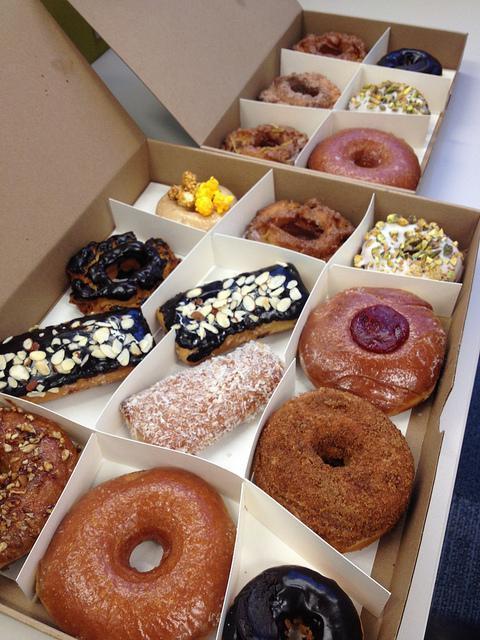How many donuts are in the picture?
Give a very brief answer. 13. How many cakes are visible?
Give a very brief answer. 2. 